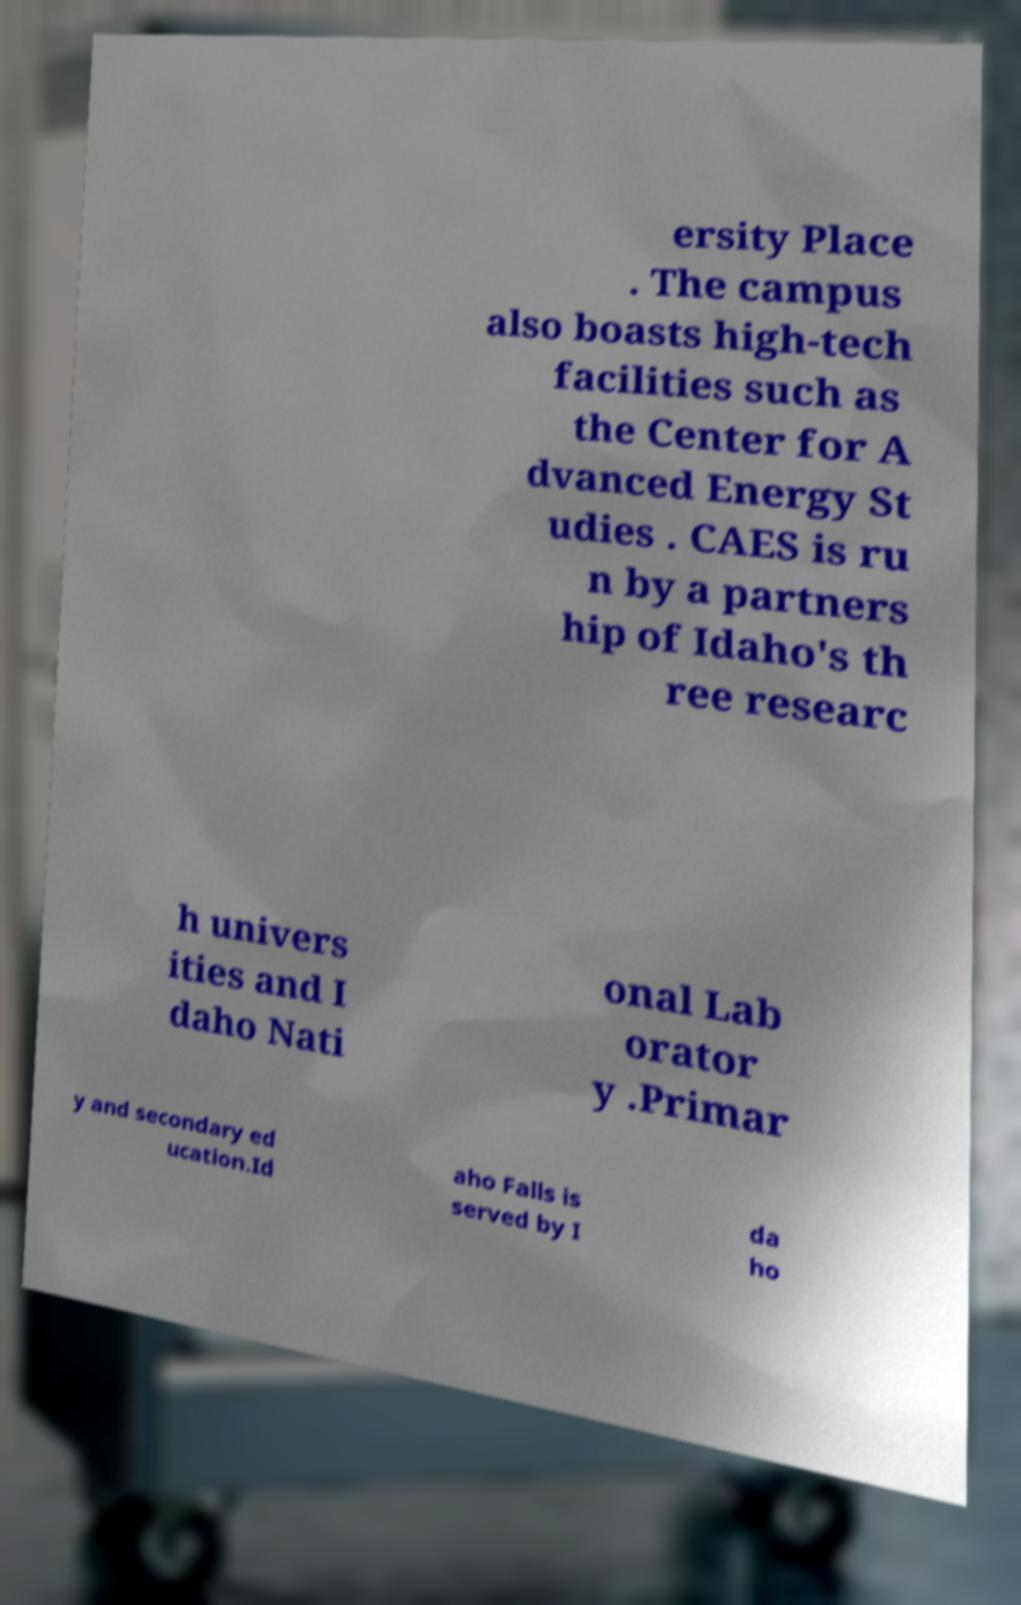Can you accurately transcribe the text from the provided image for me? ersity Place . The campus also boasts high-tech facilities such as the Center for A dvanced Energy St udies . CAES is ru n by a partners hip of Idaho's th ree researc h univers ities and I daho Nati onal Lab orator y .Primar y and secondary ed ucation.Id aho Falls is served by I da ho 